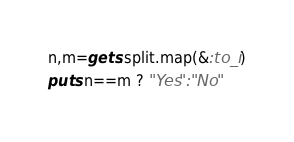Convert code to text. <code><loc_0><loc_0><loc_500><loc_500><_Ruby_>n,m=gets.split.map(&:to_i)
puts n==m ? "Yes":"No"
</code> 